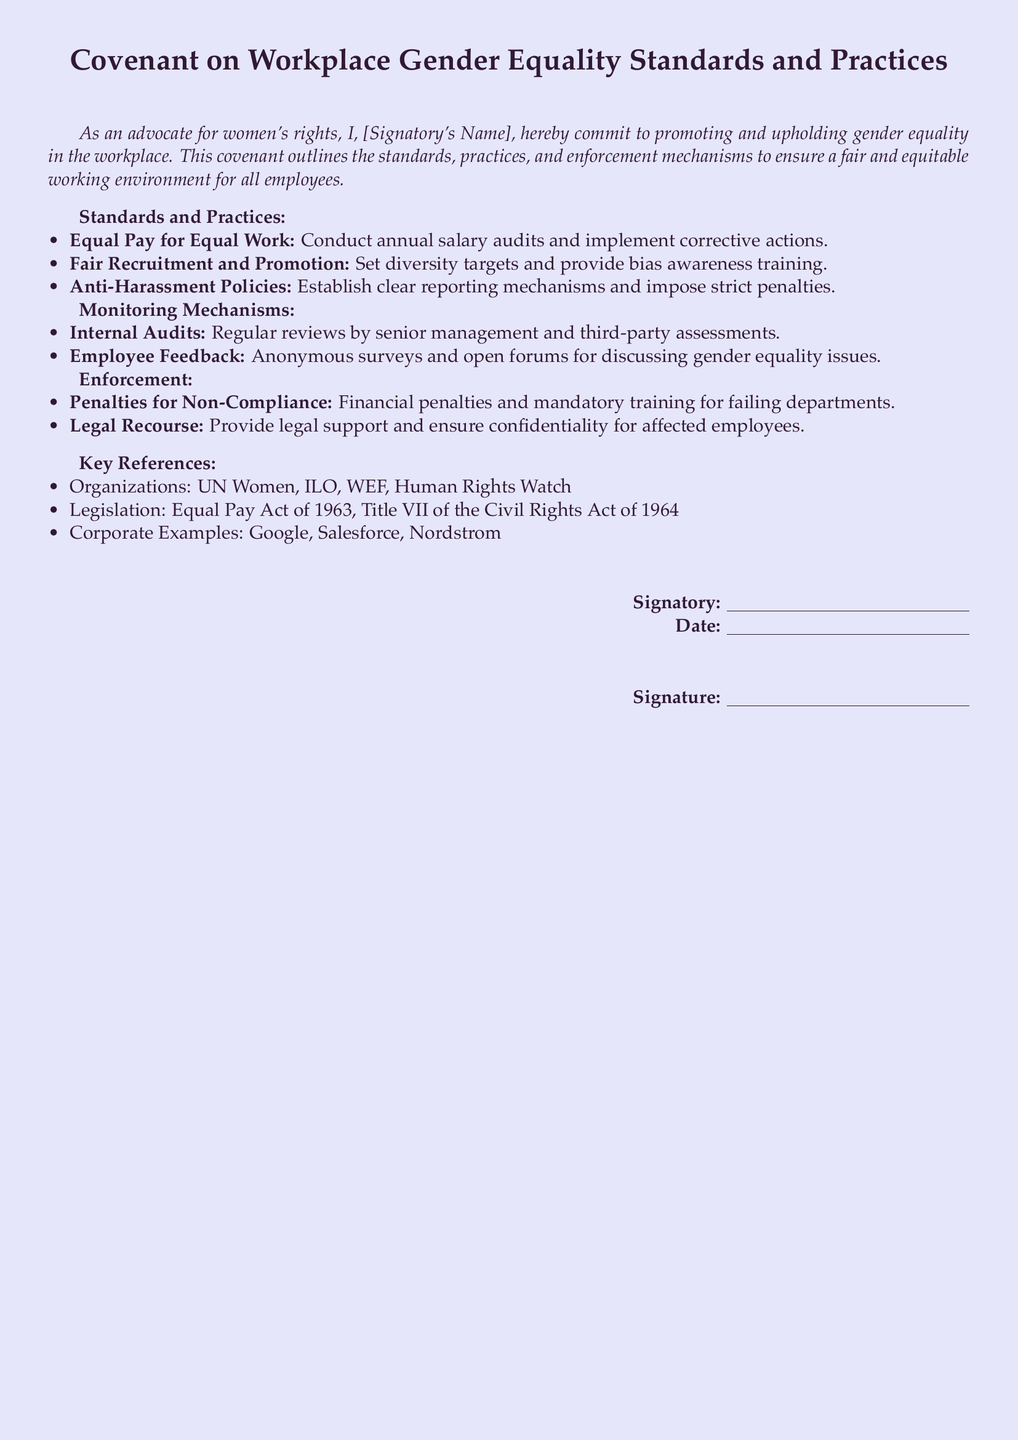What is the title of the document? The title of the document is located at the beginning of the rendered document.
Answer: Covenant on Workplace Gender Equality Standards and Practices Who commits to promoting gender equality? The signatory's role is to commit to gender equality, as stated in the introduction.
Answer: [Signatory's Name] What is the first standard listed under Standards and Practices? The first standard mentioned in the document outlines the principle of equal pay.
Answer: Equal Pay for Equal Work What is one method of monitoring mentioned? The document specifies internal audits as a monitoring method.
Answer: Internal Audits What kind of penalties are described for non-compliance? The enforcement section of the document lists specific consequences for failing to meet the standards.
Answer: Financial penalties Which organization is referenced in the Key References section? The document lists various organizations that relate to workplace gender equality standards.
Answer: UN Women What legislation is noted in the document? The document mentions significant laws relevant to gender equality in the workplace.
Answer: Equal Pay Act of 1963 What is one corporate example included? The Key References section provides examples of companies recognized for their practices.
Answer: Google What kind of training is required for failing departments? The enforcement section specifies that departments not in compliance must undergo certain training.
Answer: Mandatory training 